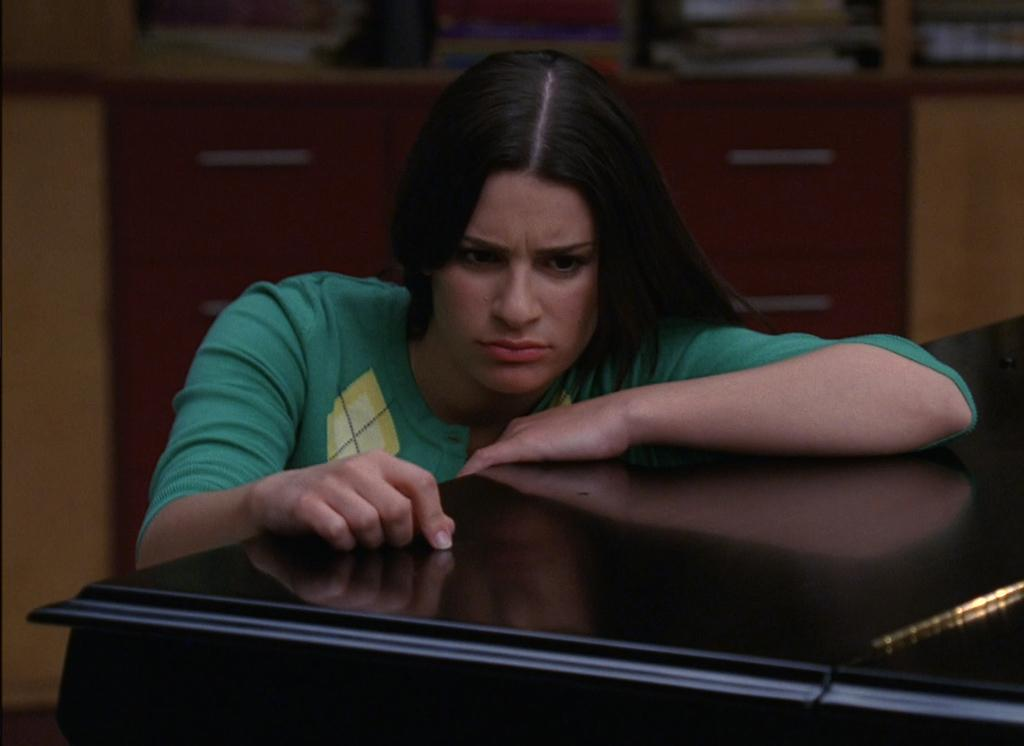Who is present in the image? There is a woman in the image. What is the woman doing in the image? The woman is beside a table and looking at the table. What can be seen in the background of the image? There is a cupboard in the background of the image. What is inside the cupboard? There are books placed in the cupboard. What type of stem can be seen growing from the woman's head in the image? There is no stem growing from the woman's head in the image. How does the woman's temper affect the room in the image? The woman's temper is not mentioned in the image, and there is no indication of how it might affect the room. 